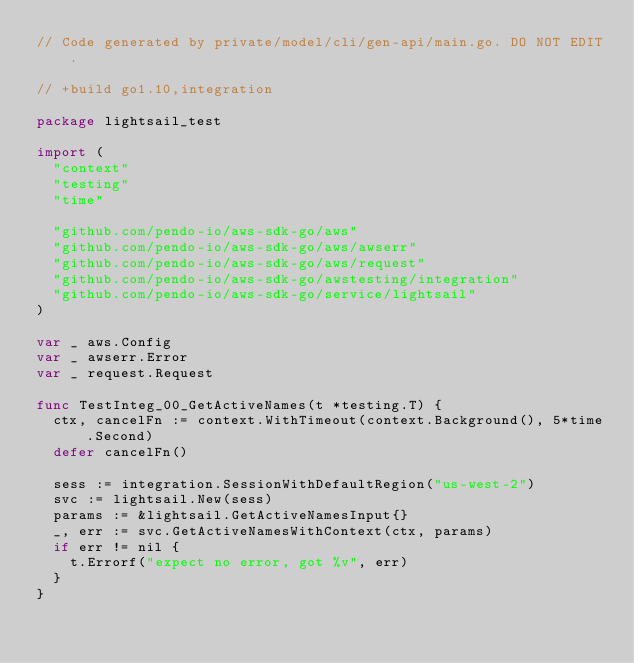<code> <loc_0><loc_0><loc_500><loc_500><_Go_>// Code generated by private/model/cli/gen-api/main.go. DO NOT EDIT.

// +build go1.10,integration

package lightsail_test

import (
	"context"
	"testing"
	"time"

	"github.com/pendo-io/aws-sdk-go/aws"
	"github.com/pendo-io/aws-sdk-go/aws/awserr"
	"github.com/pendo-io/aws-sdk-go/aws/request"
	"github.com/pendo-io/aws-sdk-go/awstesting/integration"
	"github.com/pendo-io/aws-sdk-go/service/lightsail"
)

var _ aws.Config
var _ awserr.Error
var _ request.Request

func TestInteg_00_GetActiveNames(t *testing.T) {
	ctx, cancelFn := context.WithTimeout(context.Background(), 5*time.Second)
	defer cancelFn()

	sess := integration.SessionWithDefaultRegion("us-west-2")
	svc := lightsail.New(sess)
	params := &lightsail.GetActiveNamesInput{}
	_, err := svc.GetActiveNamesWithContext(ctx, params)
	if err != nil {
		t.Errorf("expect no error, got %v", err)
	}
}
</code> 